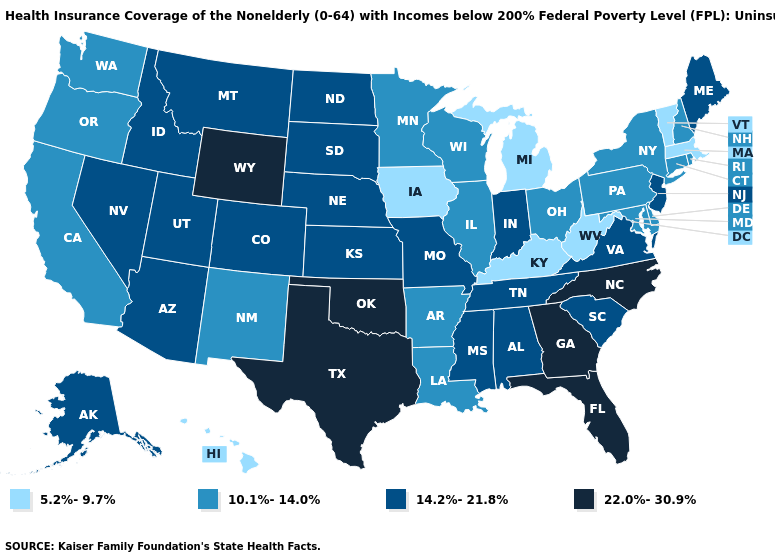Name the states that have a value in the range 22.0%-30.9%?
Answer briefly. Florida, Georgia, North Carolina, Oklahoma, Texas, Wyoming. What is the highest value in states that border Arkansas?
Keep it brief. 22.0%-30.9%. What is the lowest value in states that border New Mexico?
Concise answer only. 14.2%-21.8%. Name the states that have a value in the range 22.0%-30.9%?
Answer briefly. Florida, Georgia, North Carolina, Oklahoma, Texas, Wyoming. Name the states that have a value in the range 5.2%-9.7%?
Give a very brief answer. Hawaii, Iowa, Kentucky, Massachusetts, Michigan, Vermont, West Virginia. What is the lowest value in states that border Montana?
Quick response, please. 14.2%-21.8%. Which states have the lowest value in the West?
Concise answer only. Hawaii. What is the lowest value in states that border Washington?
Be succinct. 10.1%-14.0%. Which states have the lowest value in the South?
Be succinct. Kentucky, West Virginia. Does Maine have the highest value in the Northeast?
Short answer required. Yes. What is the value of Wisconsin?
Give a very brief answer. 10.1%-14.0%. Name the states that have a value in the range 10.1%-14.0%?
Short answer required. Arkansas, California, Connecticut, Delaware, Illinois, Louisiana, Maryland, Minnesota, New Hampshire, New Mexico, New York, Ohio, Oregon, Pennsylvania, Rhode Island, Washington, Wisconsin. What is the value of Nevada?
Concise answer only. 14.2%-21.8%. What is the value of Michigan?
Keep it brief. 5.2%-9.7%. Does the first symbol in the legend represent the smallest category?
Write a very short answer. Yes. 